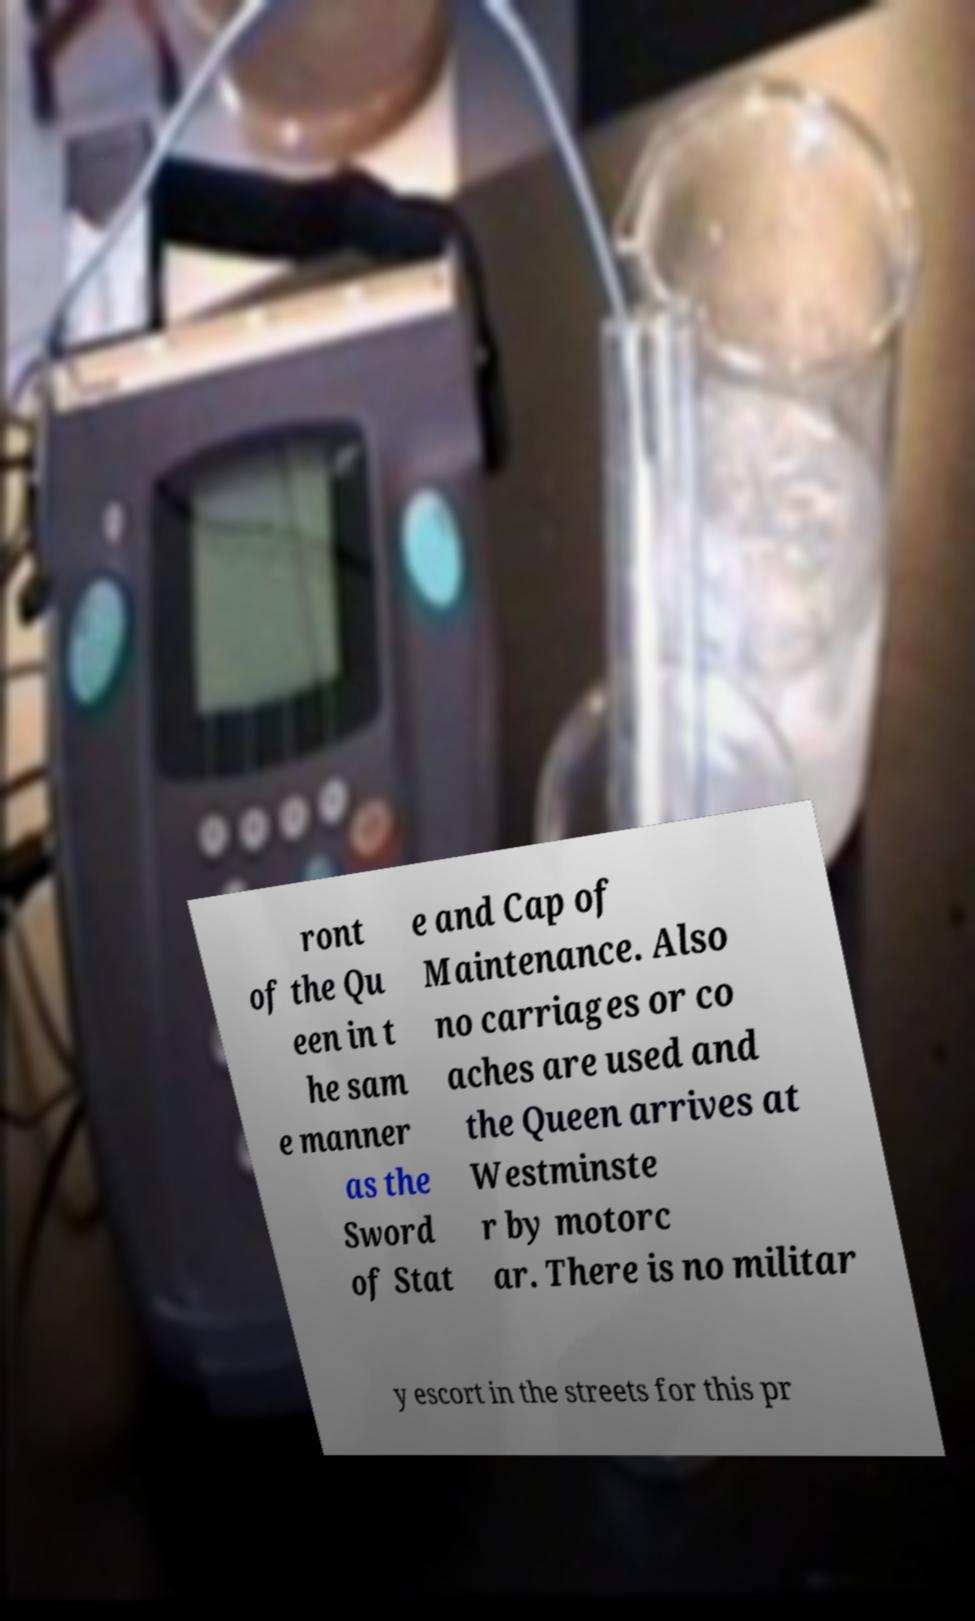Please read and relay the text visible in this image. What does it say? ront of the Qu een in t he sam e manner as the Sword of Stat e and Cap of Maintenance. Also no carriages or co aches are used and the Queen arrives at Westminste r by motorc ar. There is no militar y escort in the streets for this pr 